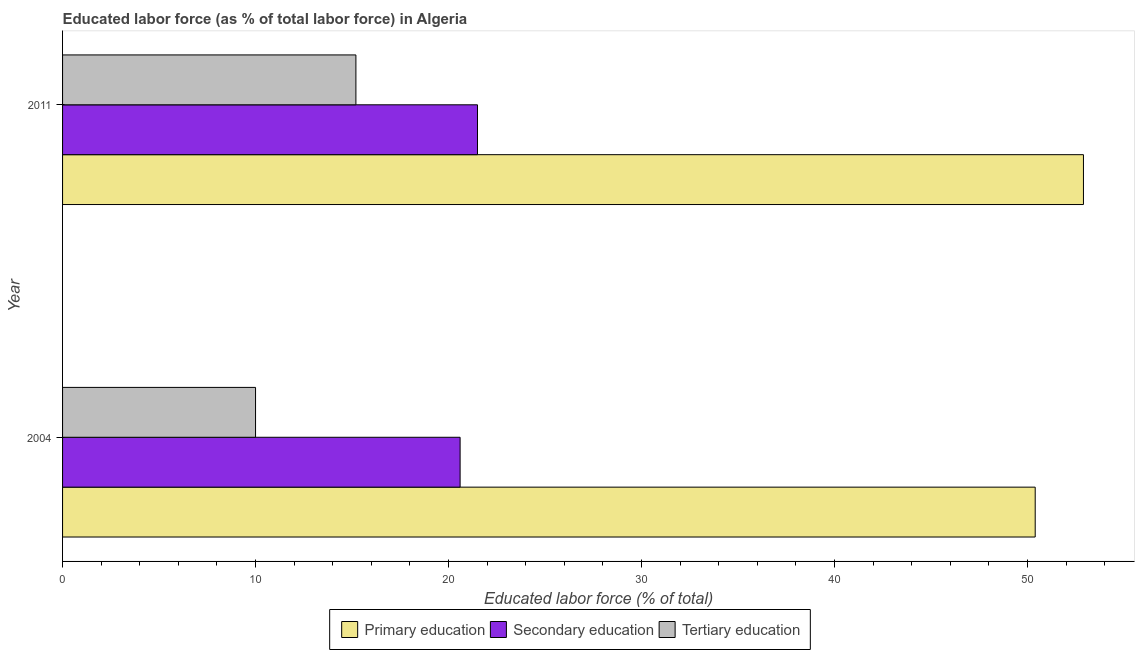How many bars are there on the 2nd tick from the top?
Your response must be concise. 3. How many bars are there on the 1st tick from the bottom?
Offer a very short reply. 3. In how many cases, is the number of bars for a given year not equal to the number of legend labels?
Your answer should be compact. 0. What is the percentage of labor force who received primary education in 2004?
Ensure brevity in your answer.  50.4. Across all years, what is the minimum percentage of labor force who received secondary education?
Keep it short and to the point. 20.6. What is the total percentage of labor force who received primary education in the graph?
Ensure brevity in your answer.  103.3. What is the difference between the percentage of labor force who received primary education in 2004 and the percentage of labor force who received tertiary education in 2011?
Your response must be concise. 35.2. What is the average percentage of labor force who received tertiary education per year?
Your response must be concise. 12.6. In how many years, is the percentage of labor force who received tertiary education greater than 2 %?
Ensure brevity in your answer.  2. What is the ratio of the percentage of labor force who received primary education in 2004 to that in 2011?
Ensure brevity in your answer.  0.95. Is the percentage of labor force who received tertiary education in 2004 less than that in 2011?
Give a very brief answer. Yes. In how many years, is the percentage of labor force who received primary education greater than the average percentage of labor force who received primary education taken over all years?
Your answer should be compact. 1. What does the 3rd bar from the top in 2004 represents?
Make the answer very short. Primary education. What does the 2nd bar from the bottom in 2011 represents?
Offer a very short reply. Secondary education. How many bars are there?
Give a very brief answer. 6. Are all the bars in the graph horizontal?
Keep it short and to the point. Yes. How many years are there in the graph?
Give a very brief answer. 2. Are the values on the major ticks of X-axis written in scientific E-notation?
Ensure brevity in your answer.  No. Does the graph contain grids?
Your response must be concise. No. What is the title of the graph?
Keep it short and to the point. Educated labor force (as % of total labor force) in Algeria. Does "Social Protection" appear as one of the legend labels in the graph?
Your response must be concise. No. What is the label or title of the X-axis?
Offer a very short reply. Educated labor force (% of total). What is the label or title of the Y-axis?
Your answer should be very brief. Year. What is the Educated labor force (% of total) in Primary education in 2004?
Make the answer very short. 50.4. What is the Educated labor force (% of total) in Secondary education in 2004?
Offer a terse response. 20.6. What is the Educated labor force (% of total) of Primary education in 2011?
Offer a terse response. 52.9. What is the Educated labor force (% of total) of Secondary education in 2011?
Your answer should be compact. 21.5. What is the Educated labor force (% of total) in Tertiary education in 2011?
Provide a short and direct response. 15.2. Across all years, what is the maximum Educated labor force (% of total) of Primary education?
Make the answer very short. 52.9. Across all years, what is the maximum Educated labor force (% of total) of Secondary education?
Provide a succinct answer. 21.5. Across all years, what is the maximum Educated labor force (% of total) of Tertiary education?
Offer a very short reply. 15.2. Across all years, what is the minimum Educated labor force (% of total) in Primary education?
Keep it short and to the point. 50.4. Across all years, what is the minimum Educated labor force (% of total) of Secondary education?
Ensure brevity in your answer.  20.6. Across all years, what is the minimum Educated labor force (% of total) in Tertiary education?
Your answer should be very brief. 10. What is the total Educated labor force (% of total) in Primary education in the graph?
Provide a short and direct response. 103.3. What is the total Educated labor force (% of total) of Secondary education in the graph?
Your answer should be very brief. 42.1. What is the total Educated labor force (% of total) of Tertiary education in the graph?
Make the answer very short. 25.2. What is the difference between the Educated labor force (% of total) in Secondary education in 2004 and that in 2011?
Offer a very short reply. -0.9. What is the difference between the Educated labor force (% of total) of Primary education in 2004 and the Educated labor force (% of total) of Secondary education in 2011?
Make the answer very short. 28.9. What is the difference between the Educated labor force (% of total) of Primary education in 2004 and the Educated labor force (% of total) of Tertiary education in 2011?
Provide a short and direct response. 35.2. What is the difference between the Educated labor force (% of total) of Secondary education in 2004 and the Educated labor force (% of total) of Tertiary education in 2011?
Provide a short and direct response. 5.4. What is the average Educated labor force (% of total) in Primary education per year?
Keep it short and to the point. 51.65. What is the average Educated labor force (% of total) of Secondary education per year?
Ensure brevity in your answer.  21.05. In the year 2004, what is the difference between the Educated labor force (% of total) in Primary education and Educated labor force (% of total) in Secondary education?
Make the answer very short. 29.8. In the year 2004, what is the difference between the Educated labor force (% of total) in Primary education and Educated labor force (% of total) in Tertiary education?
Provide a succinct answer. 40.4. In the year 2011, what is the difference between the Educated labor force (% of total) of Primary education and Educated labor force (% of total) of Secondary education?
Make the answer very short. 31.4. In the year 2011, what is the difference between the Educated labor force (% of total) in Primary education and Educated labor force (% of total) in Tertiary education?
Your answer should be compact. 37.7. What is the ratio of the Educated labor force (% of total) in Primary education in 2004 to that in 2011?
Make the answer very short. 0.95. What is the ratio of the Educated labor force (% of total) in Secondary education in 2004 to that in 2011?
Provide a succinct answer. 0.96. What is the ratio of the Educated labor force (% of total) of Tertiary education in 2004 to that in 2011?
Your answer should be compact. 0.66. What is the difference between the highest and the lowest Educated labor force (% of total) in Secondary education?
Your response must be concise. 0.9. 